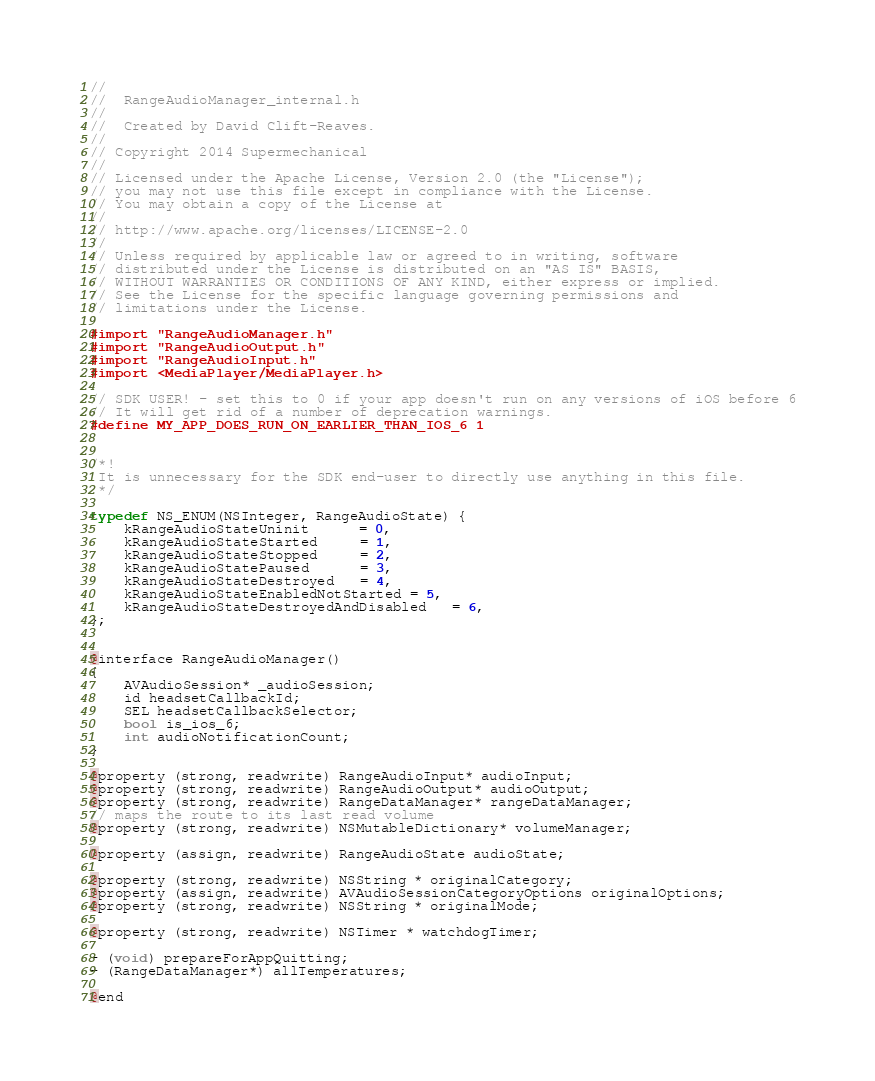<code> <loc_0><loc_0><loc_500><loc_500><_C_>//
//  RangeAudioManager_internal.h
//
//  Created by David Clift-Reaves.
//
// Copyright 2014 Supermechanical
//
// Licensed under the Apache License, Version 2.0 (the "License");
// you may not use this file except in compliance with the License.
// You may obtain a copy of the License at
//
// http://www.apache.org/licenses/LICENSE-2.0
//
// Unless required by applicable law or agreed to in writing, software
// distributed under the License is distributed on an "AS IS" BASIS,
// WITHOUT WARRANTIES OR CONDITIONS OF ANY KIND, either express or implied.
// See the License for the specific language governing permissions and
// limitations under the License.

#import "RangeAudioManager.h"
#import "RangeAudioOutput.h"
#import "RangeAudioInput.h"
#import <MediaPlayer/MediaPlayer.h>

// SDK USER! - set this to 0 if your app doesn't run on any versions of iOS before 6
// It will get rid of a number of deprecation warnings.
#define MY_APP_DOES_RUN_ON_EARLIER_THAN_IOS_6 1


/*!
 It is unnecessary for the SDK end-user to directly use anything in this file.
 */

typedef NS_ENUM(NSInteger, RangeAudioState) {
    kRangeAudioStateUninit      = 0,
    kRangeAudioStateStarted     = 1,
    kRangeAudioStateStopped     = 2,
    kRangeAudioStatePaused      = 3,
    kRangeAudioStateDestroyed   = 4,
    kRangeAudioStateEnabledNotStarted = 5,
    kRangeAudioStateDestroyedAndDisabled   = 6,
};


@interface RangeAudioManager()
{
    AVAudioSession* _audioSession;
    id headsetCallbackId;
    SEL headsetCallbackSelector;
    bool is_ios_6;
    int audioNotificationCount;
}

@property (strong, readwrite) RangeAudioInput* audioInput;
@property (strong, readwrite) RangeAudioOutput* audioOutput;
@property (strong, readwrite) RangeDataManager* rangeDataManager;
// maps the route to its last read volume
@property (strong, readwrite) NSMutableDictionary* volumeManager;

@property (assign, readwrite) RangeAudioState audioState;

@property (strong, readwrite) NSString * originalCategory;
@property (assign, readwrite) AVAudioSessionCategoryOptions originalOptions;
@property (strong, readwrite) NSString * originalMode;

@property (strong, readwrite) NSTimer * watchdogTimer;

- (void) prepareForAppQuitting;
- (RangeDataManager*) allTemperatures;

@end
</code> 